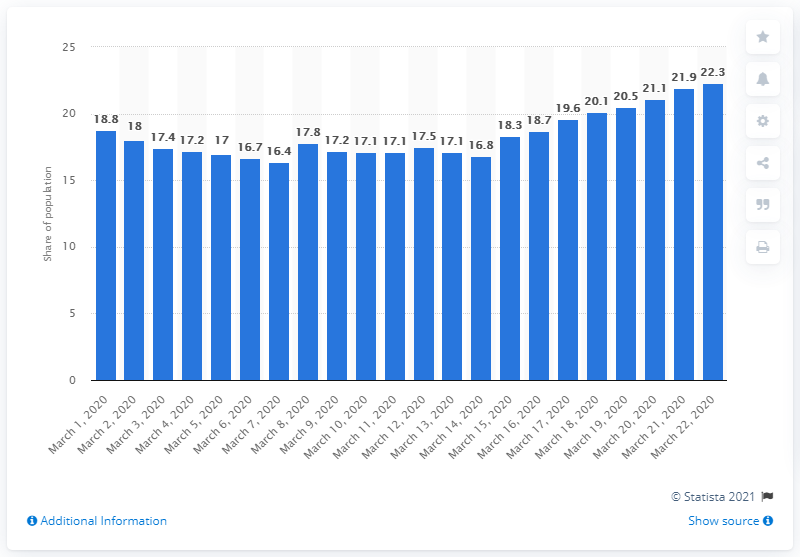Highlight a few significant elements in this photo. On average, 18.8% of Brazilians were watching TV during the period of March 1 and March 22. 